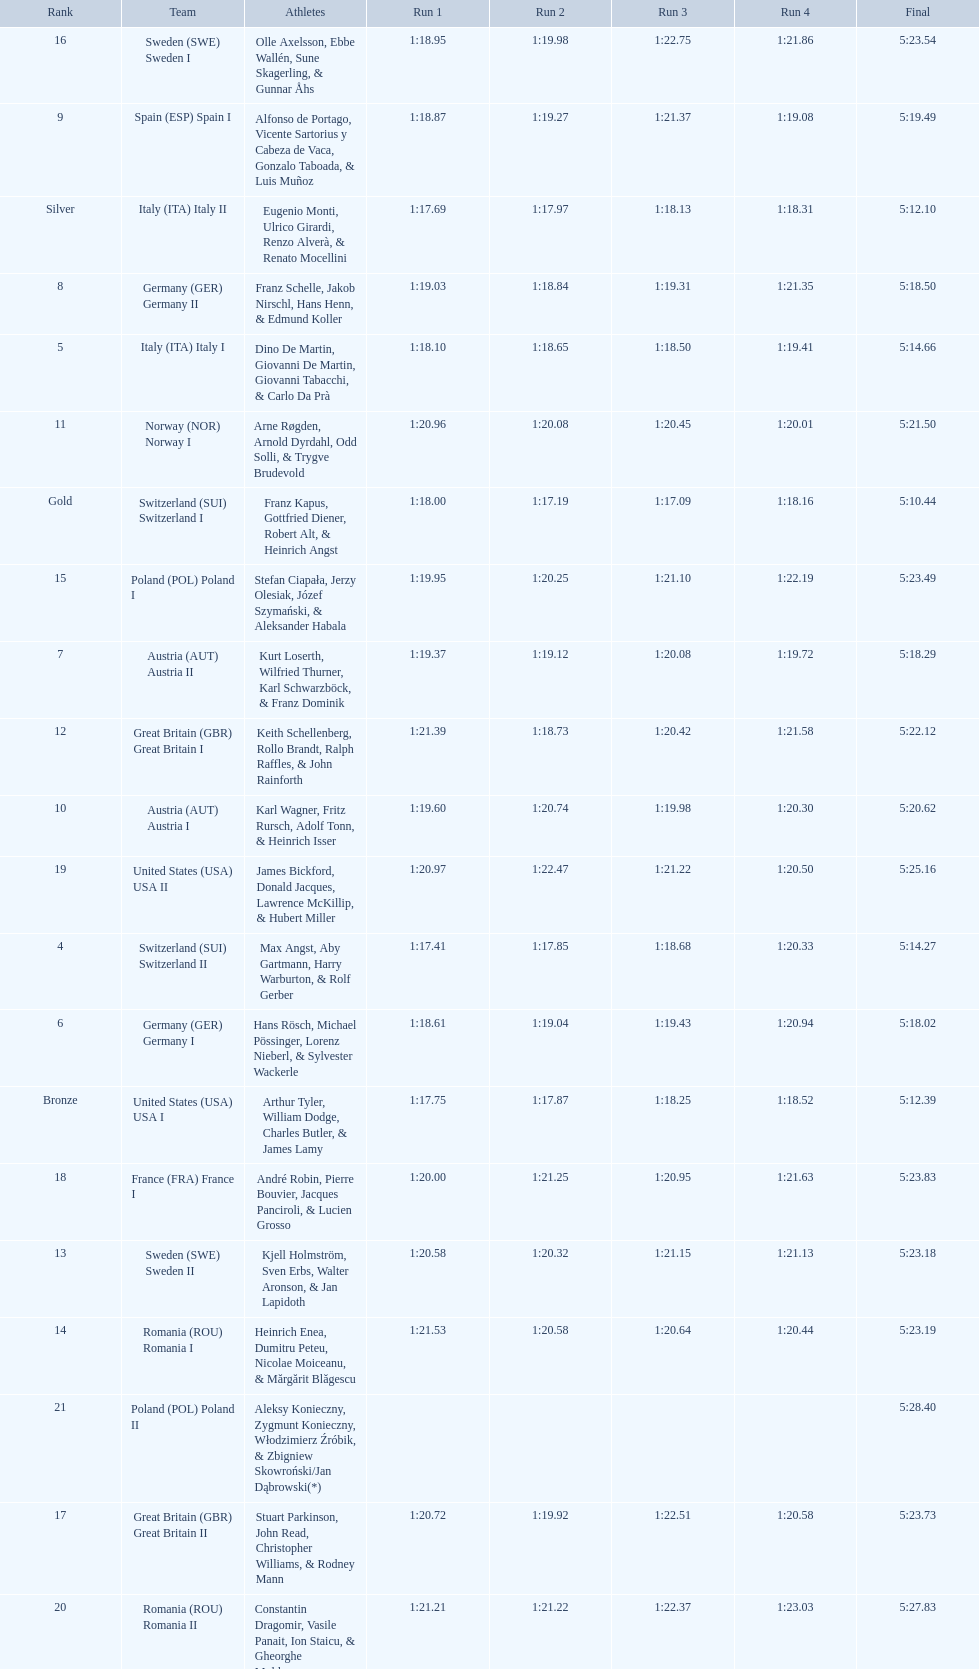What team comes after italy (ita) italy i? Germany I. 